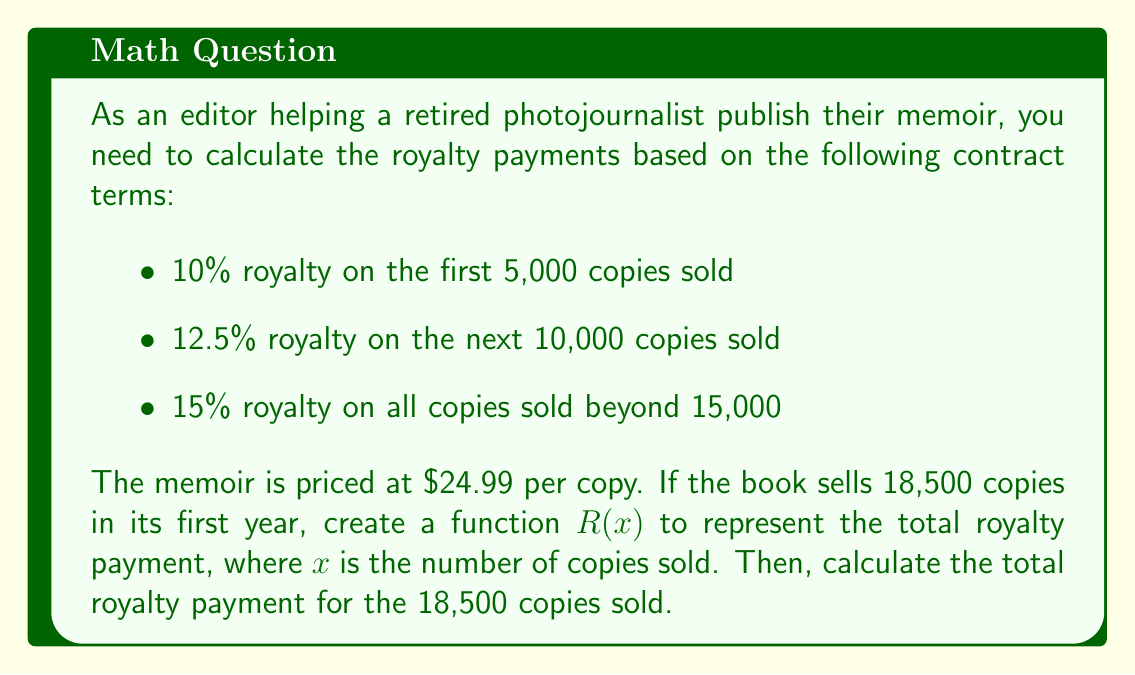Provide a solution to this math problem. To solve this problem, we need to create a piecewise function $R(x)$ that represents the total royalty payment based on the number of copies sold. Then, we'll evaluate this function for $x = 18,500$.

Let's break down the function into three parts:

1. For $0 \leq x \leq 5,000$:
   $R_1(x) = 0.10 \cdot 24.99 \cdot x$

2. For $5,000 < x \leq 15,000$:
   $R_2(x) = R_1(5000) + 0.125 \cdot 24.99 \cdot (x - 5000)$

3. For $x > 15,000$:
   $R_3(x) = R_2(15000) + 0.15 \cdot 24.99 \cdot (x - 15000)$

Now, we can write the piecewise function $R(x)$:

$$R(x) = \begin{cases}
0.10 \cdot 24.99 \cdot x & \text{if } 0 \leq x \leq 5,000 \\
R_1(5000) + 0.125 \cdot 24.99 \cdot (x - 5000) & \text{if } 5,000 < x \leq 15,000 \\
R_2(15000) + 0.15 \cdot 24.99 \cdot (x - 15000) & \text{if } x > 15,000
\end{cases}$$

To calculate the total royalty payment for 18,500 copies, we need to evaluate $R(18500)$:

1. Calculate $R_1(5000)$:
   $R_1(5000) = 0.10 \cdot 24.99 \cdot 5000 = 12,495$

2. Calculate $R_2(15000)$:
   $R_2(15000) = 12,495 + 0.125 \cdot 24.99 \cdot (15000 - 5000) = 43,732.50$

3. Calculate $R(18500)$:
   $R(18500) = 43,732.50 + 0.15 \cdot 24.99 \cdot (18500 - 15000) = 52,106.25$

Therefore, the total royalty payment for 18,500 copies sold is $52,106.25.
Answer: $52,106.25 